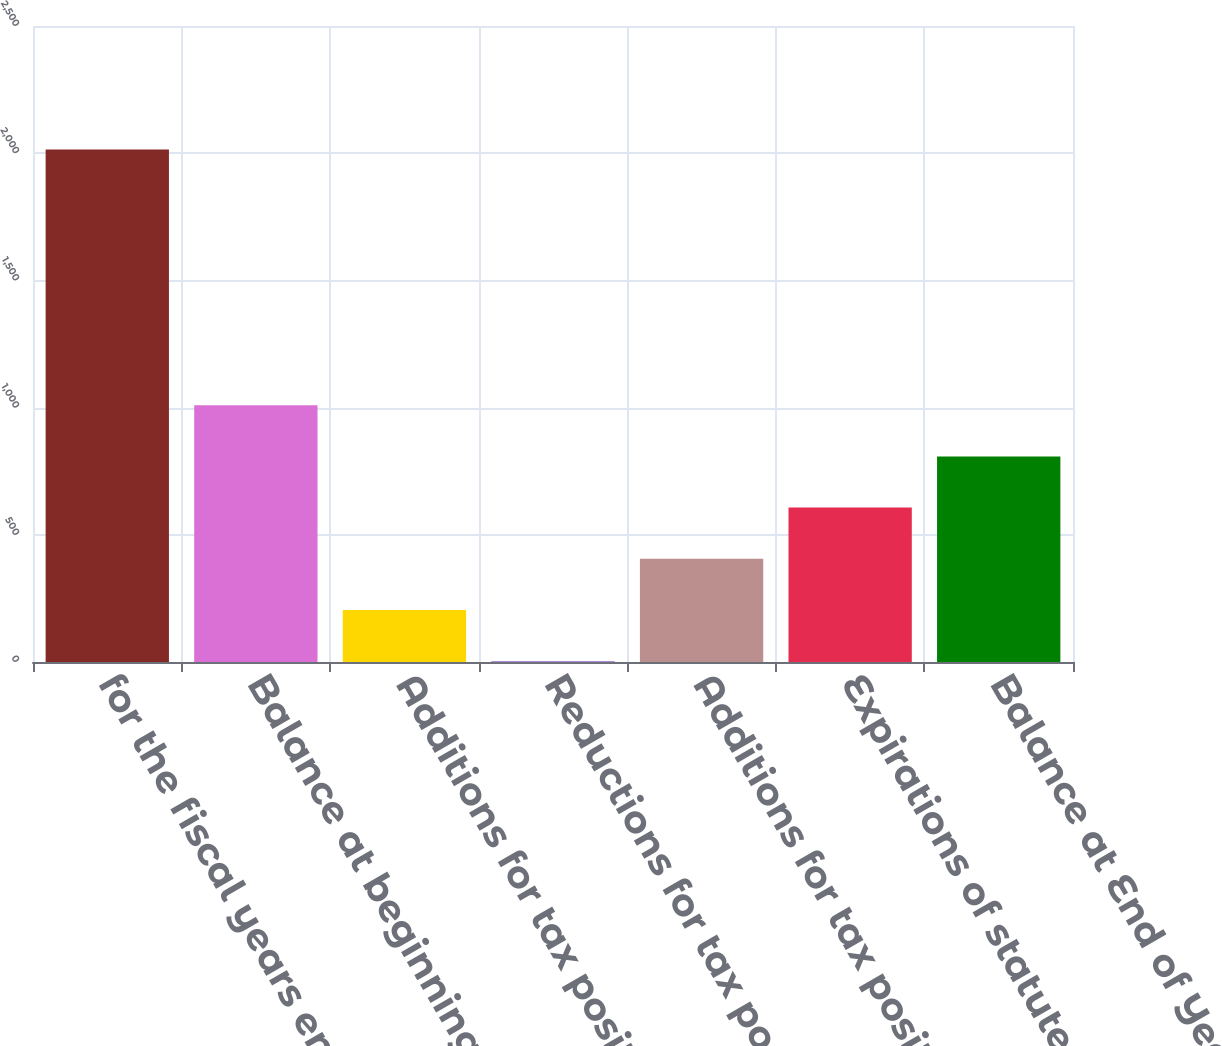Convert chart. <chart><loc_0><loc_0><loc_500><loc_500><bar_chart><fcel>for the fiscal years ended<fcel>Balance at beginning of year<fcel>Additions for tax positions of<fcel>Reductions for tax positions<fcel>Additions for tax positions<fcel>Expirations of statute of<fcel>Balance at End of Year<nl><fcel>2015<fcel>1009.2<fcel>204.56<fcel>3.4<fcel>405.72<fcel>606.88<fcel>808.04<nl></chart> 